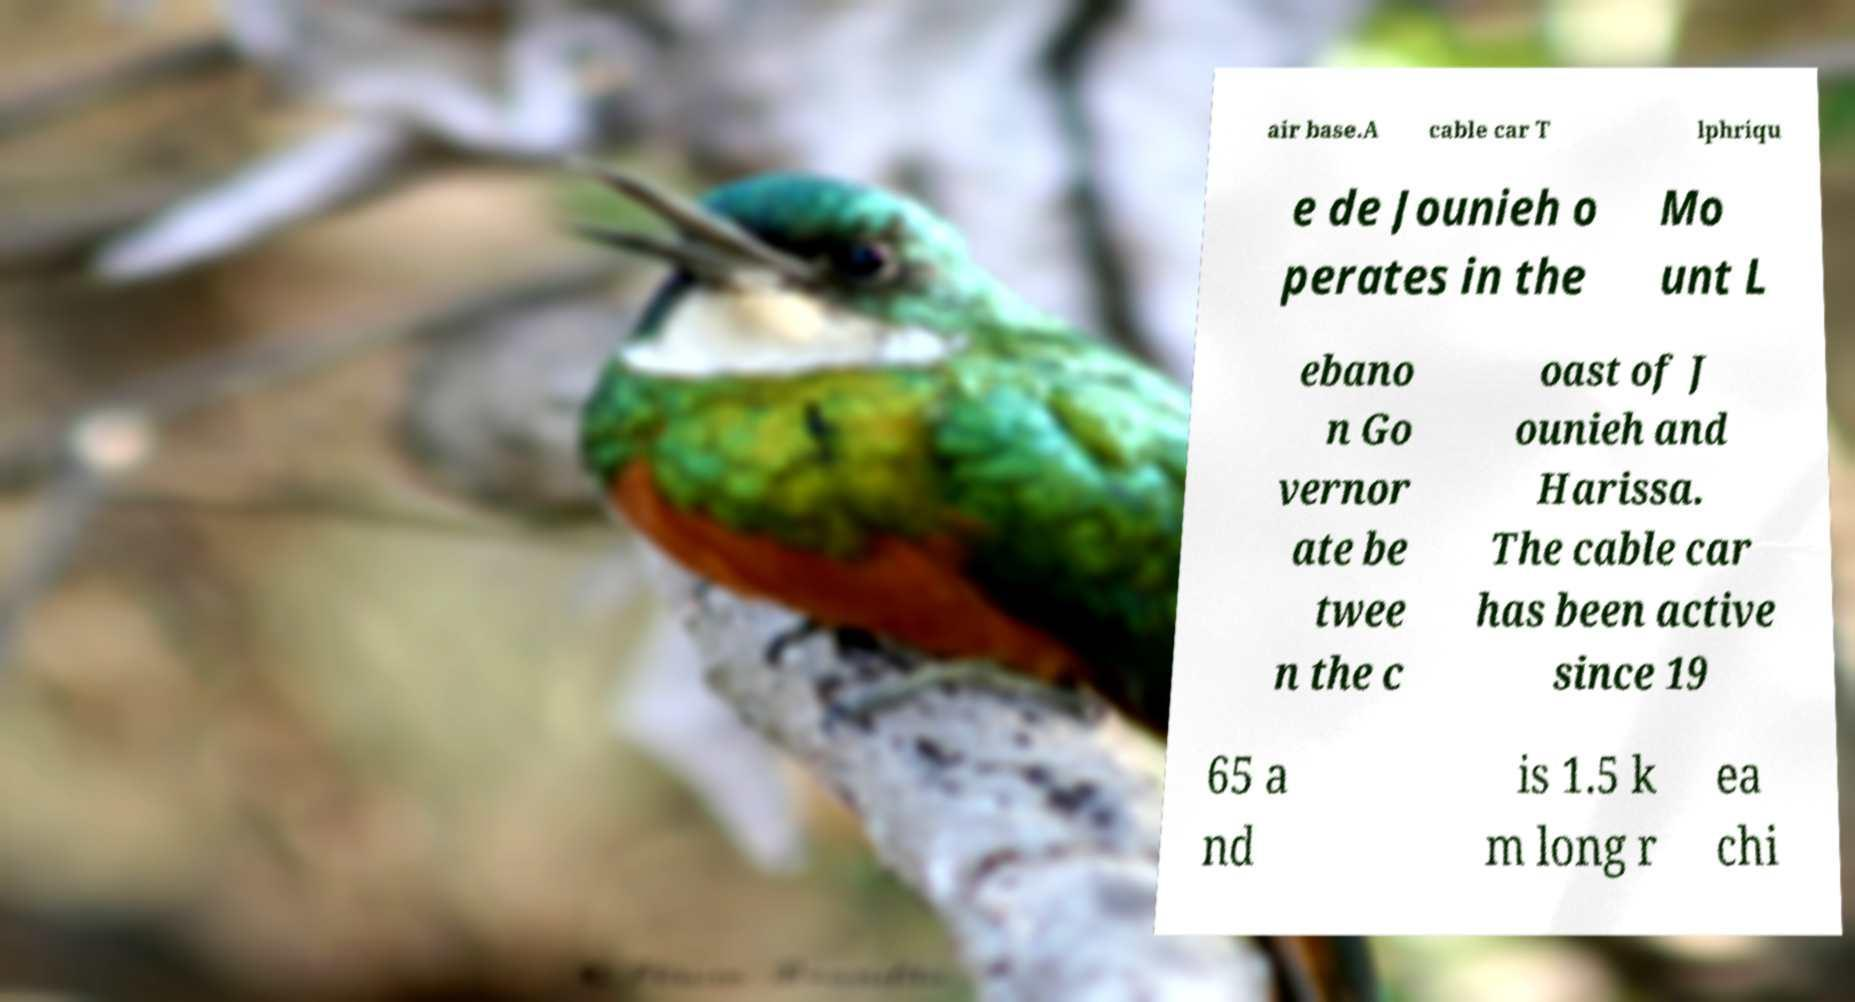Could you assist in decoding the text presented in this image and type it out clearly? air base.A cable car T lphriqu e de Jounieh o perates in the Mo unt L ebano n Go vernor ate be twee n the c oast of J ounieh and Harissa. The cable car has been active since 19 65 a nd is 1.5 k m long r ea chi 